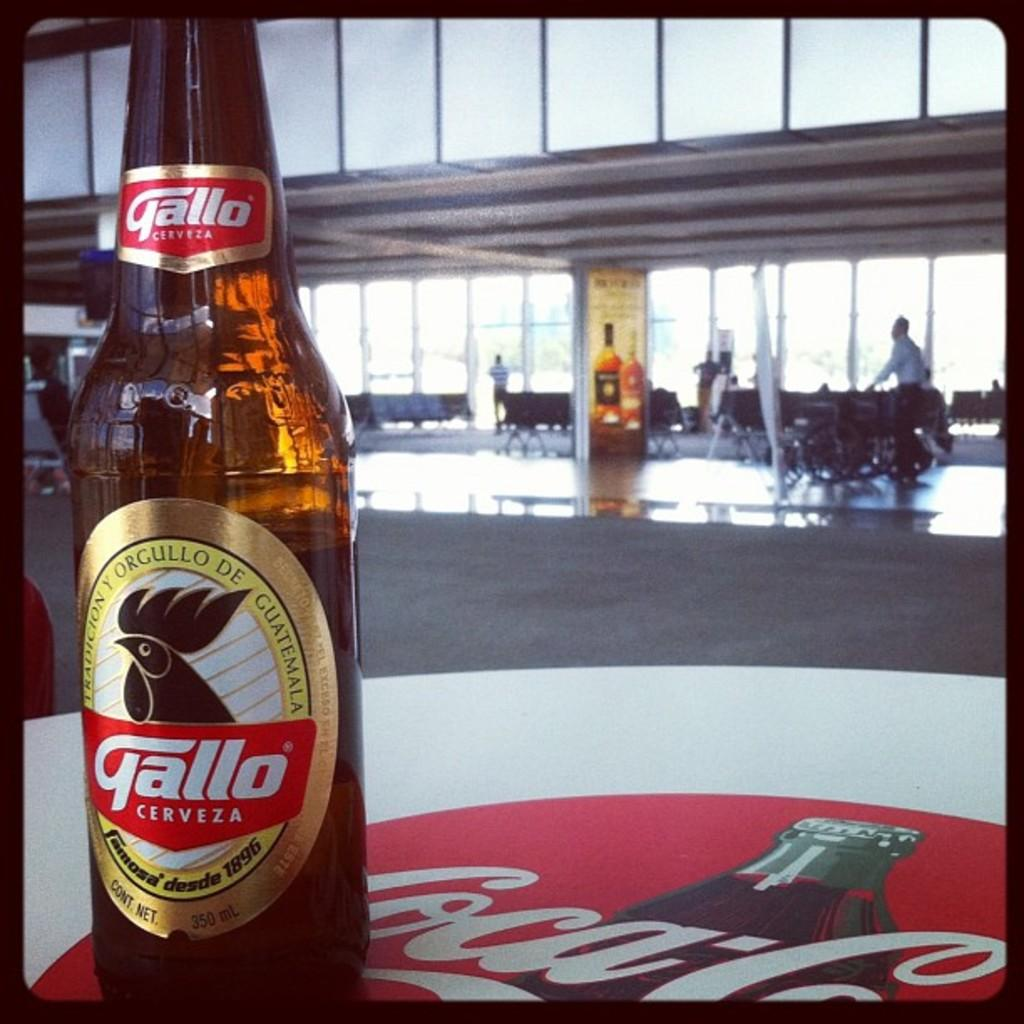<image>
Create a compact narrative representing the image presented. A bottle with the brand of Gallo sits on a table that says Coca-Cola. 